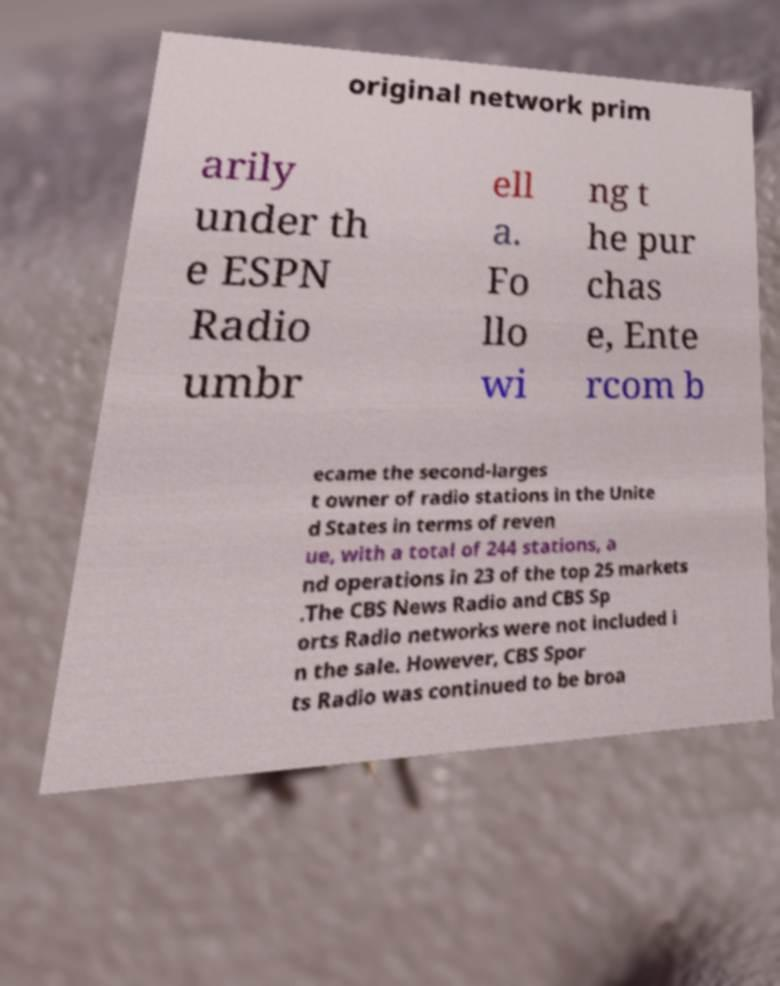Could you extract and type out the text from this image? original network prim arily under th e ESPN Radio umbr ell a. Fo llo wi ng t he pur chas e, Ente rcom b ecame the second-larges t owner of radio stations in the Unite d States in terms of reven ue, with a total of 244 stations, a nd operations in 23 of the top 25 markets .The CBS News Radio and CBS Sp orts Radio networks were not included i n the sale. However, CBS Spor ts Radio was continued to be broa 